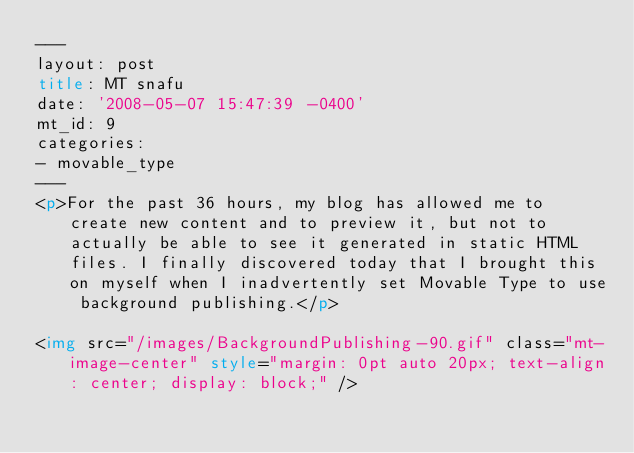<code> <loc_0><loc_0><loc_500><loc_500><_HTML_>---
layout: post
title: MT snafu
date: '2008-05-07 15:47:39 -0400'
mt_id: 9
categories:
- movable_type
---
<p>For the past 36 hours, my blog has allowed me to create new content and to preview it, but not to actually be able to see it generated in static HTML files. I finally discovered today that I brought this on myself when I inadvertently set Movable Type to use background publishing.</p>

<img src="/images/BackgroundPublishing-90.gif" class="mt-image-center" style="margin: 0pt auto 20px; text-align: center; display: block;" />
</code> 